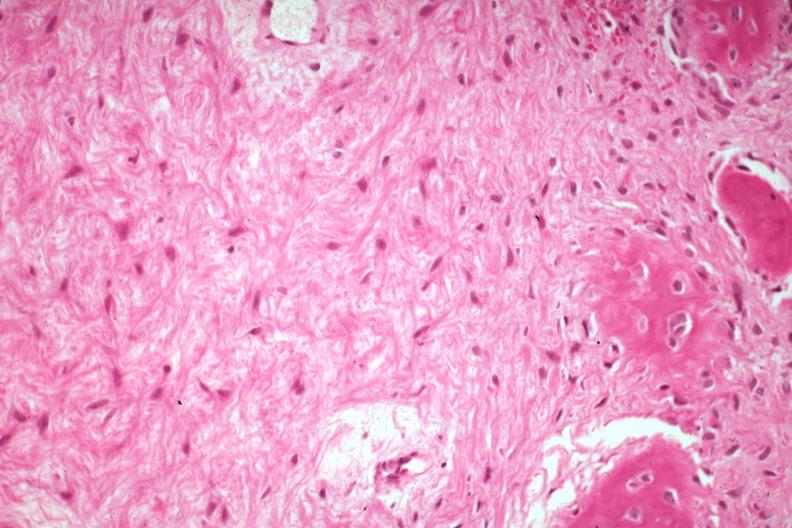how does this image show high good example bone formation?
Answer the question using a single word or phrase. With osteoid and osteoblasts 